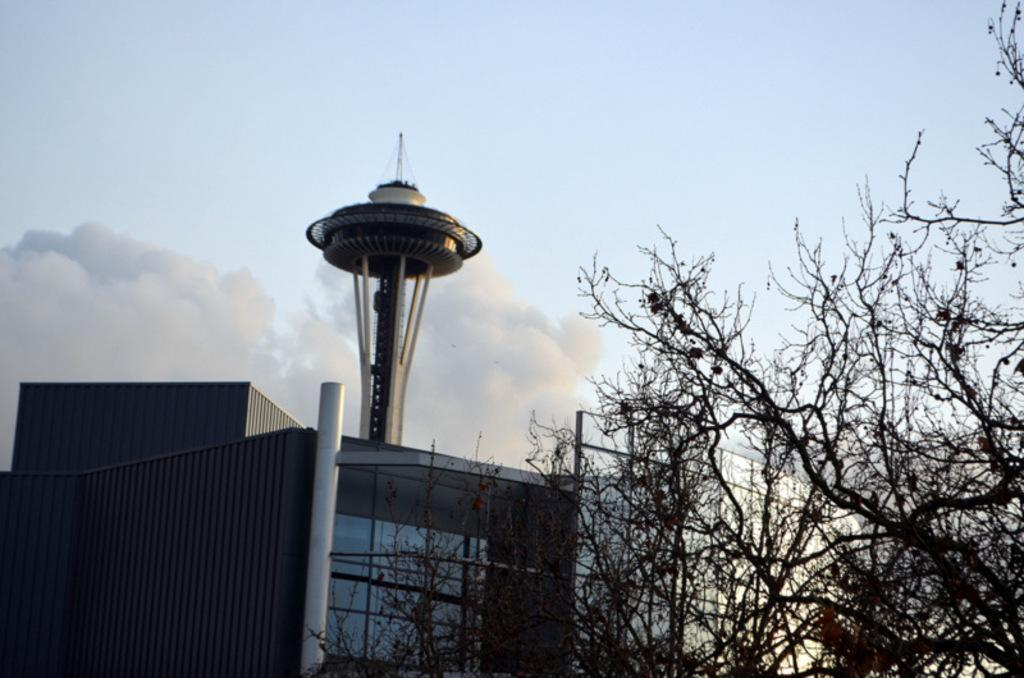What is located in the middle of the image? There are trees in the middle of the image. What can be seen in the background of the image? There is a building and a tower in the background of the image. What is visible in the sky in the background of the image? There are clouds in the sky in the background of the image. What type of card is being used to stop the tower from falling in the image? There is no card or indication of a tower falling in the image. How many trays can be seen on the trees in the image? There are no trays present in the image; it features trees, a building, and a tower in the background. 